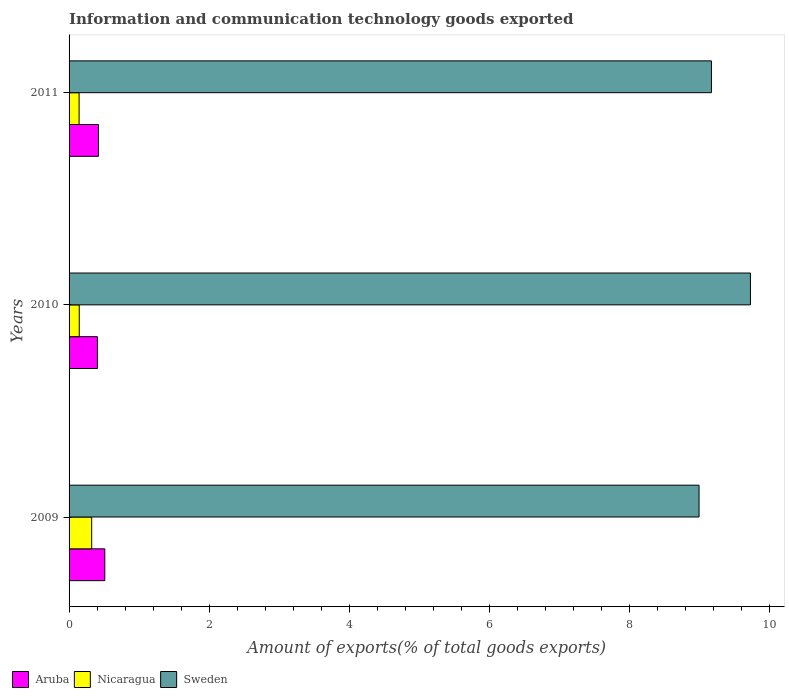Are the number of bars per tick equal to the number of legend labels?
Give a very brief answer. Yes. Are the number of bars on each tick of the Y-axis equal?
Your response must be concise. Yes. How many bars are there on the 2nd tick from the top?
Offer a terse response. 3. How many bars are there on the 3rd tick from the bottom?
Ensure brevity in your answer.  3. What is the label of the 2nd group of bars from the top?
Your answer should be compact. 2010. What is the amount of goods exported in Nicaragua in 2010?
Your answer should be very brief. 0.14. Across all years, what is the maximum amount of goods exported in Sweden?
Make the answer very short. 9.72. Across all years, what is the minimum amount of goods exported in Nicaragua?
Your answer should be compact. 0.14. In which year was the amount of goods exported in Sweden minimum?
Your answer should be very brief. 2009. What is the total amount of goods exported in Nicaragua in the graph?
Ensure brevity in your answer.  0.61. What is the difference between the amount of goods exported in Nicaragua in 2009 and that in 2010?
Your answer should be compact. 0.18. What is the difference between the amount of goods exported in Aruba in 2010 and the amount of goods exported in Sweden in 2009?
Your response must be concise. -8.59. What is the average amount of goods exported in Sweden per year?
Provide a succinct answer. 9.29. In the year 2010, what is the difference between the amount of goods exported in Aruba and amount of goods exported in Sweden?
Make the answer very short. -9.32. What is the ratio of the amount of goods exported in Sweden in 2010 to that in 2011?
Provide a succinct answer. 1.06. Is the amount of goods exported in Sweden in 2009 less than that in 2011?
Give a very brief answer. Yes. What is the difference between the highest and the second highest amount of goods exported in Nicaragua?
Give a very brief answer. 0.18. What is the difference between the highest and the lowest amount of goods exported in Nicaragua?
Provide a succinct answer. 0.18. In how many years, is the amount of goods exported in Aruba greater than the average amount of goods exported in Aruba taken over all years?
Make the answer very short. 1. Is the sum of the amount of goods exported in Sweden in 2009 and 2011 greater than the maximum amount of goods exported in Aruba across all years?
Provide a succinct answer. Yes. What does the 1st bar from the top in 2011 represents?
Ensure brevity in your answer.  Sweden. What does the 3rd bar from the bottom in 2009 represents?
Your answer should be very brief. Sweden. Are all the bars in the graph horizontal?
Provide a short and direct response. Yes. Are the values on the major ticks of X-axis written in scientific E-notation?
Give a very brief answer. No. Does the graph contain any zero values?
Offer a very short reply. No. Does the graph contain grids?
Your answer should be compact. No. How many legend labels are there?
Your answer should be very brief. 3. What is the title of the graph?
Your answer should be compact. Information and communication technology goods exported. What is the label or title of the X-axis?
Offer a terse response. Amount of exports(% of total goods exports). What is the label or title of the Y-axis?
Give a very brief answer. Years. What is the Amount of exports(% of total goods exports) in Aruba in 2009?
Keep it short and to the point. 0.51. What is the Amount of exports(% of total goods exports) in Nicaragua in 2009?
Make the answer very short. 0.32. What is the Amount of exports(% of total goods exports) in Sweden in 2009?
Provide a succinct answer. 8.99. What is the Amount of exports(% of total goods exports) of Aruba in 2010?
Give a very brief answer. 0.4. What is the Amount of exports(% of total goods exports) in Nicaragua in 2010?
Provide a succinct answer. 0.14. What is the Amount of exports(% of total goods exports) of Sweden in 2010?
Provide a short and direct response. 9.72. What is the Amount of exports(% of total goods exports) in Aruba in 2011?
Your response must be concise. 0.42. What is the Amount of exports(% of total goods exports) in Nicaragua in 2011?
Offer a terse response. 0.14. What is the Amount of exports(% of total goods exports) in Sweden in 2011?
Give a very brief answer. 9.17. Across all years, what is the maximum Amount of exports(% of total goods exports) of Aruba?
Make the answer very short. 0.51. Across all years, what is the maximum Amount of exports(% of total goods exports) in Nicaragua?
Offer a terse response. 0.32. Across all years, what is the maximum Amount of exports(% of total goods exports) in Sweden?
Keep it short and to the point. 9.72. Across all years, what is the minimum Amount of exports(% of total goods exports) in Aruba?
Offer a very short reply. 0.4. Across all years, what is the minimum Amount of exports(% of total goods exports) of Nicaragua?
Offer a terse response. 0.14. Across all years, what is the minimum Amount of exports(% of total goods exports) of Sweden?
Provide a short and direct response. 8.99. What is the total Amount of exports(% of total goods exports) of Aruba in the graph?
Offer a terse response. 1.33. What is the total Amount of exports(% of total goods exports) of Nicaragua in the graph?
Keep it short and to the point. 0.61. What is the total Amount of exports(% of total goods exports) in Sweden in the graph?
Give a very brief answer. 27.88. What is the difference between the Amount of exports(% of total goods exports) of Aruba in 2009 and that in 2010?
Make the answer very short. 0.11. What is the difference between the Amount of exports(% of total goods exports) in Nicaragua in 2009 and that in 2010?
Provide a succinct answer. 0.18. What is the difference between the Amount of exports(% of total goods exports) in Sweden in 2009 and that in 2010?
Your response must be concise. -0.73. What is the difference between the Amount of exports(% of total goods exports) of Aruba in 2009 and that in 2011?
Your answer should be compact. 0.09. What is the difference between the Amount of exports(% of total goods exports) in Nicaragua in 2009 and that in 2011?
Give a very brief answer. 0.18. What is the difference between the Amount of exports(% of total goods exports) in Sweden in 2009 and that in 2011?
Offer a terse response. -0.18. What is the difference between the Amount of exports(% of total goods exports) in Aruba in 2010 and that in 2011?
Offer a very short reply. -0.02. What is the difference between the Amount of exports(% of total goods exports) in Nicaragua in 2010 and that in 2011?
Offer a very short reply. 0. What is the difference between the Amount of exports(% of total goods exports) in Sweden in 2010 and that in 2011?
Provide a succinct answer. 0.56. What is the difference between the Amount of exports(% of total goods exports) in Aruba in 2009 and the Amount of exports(% of total goods exports) in Nicaragua in 2010?
Provide a short and direct response. 0.36. What is the difference between the Amount of exports(% of total goods exports) in Aruba in 2009 and the Amount of exports(% of total goods exports) in Sweden in 2010?
Keep it short and to the point. -9.21. What is the difference between the Amount of exports(% of total goods exports) of Nicaragua in 2009 and the Amount of exports(% of total goods exports) of Sweden in 2010?
Give a very brief answer. -9.4. What is the difference between the Amount of exports(% of total goods exports) in Aruba in 2009 and the Amount of exports(% of total goods exports) in Nicaragua in 2011?
Provide a short and direct response. 0.37. What is the difference between the Amount of exports(% of total goods exports) of Aruba in 2009 and the Amount of exports(% of total goods exports) of Sweden in 2011?
Ensure brevity in your answer.  -8.66. What is the difference between the Amount of exports(% of total goods exports) of Nicaragua in 2009 and the Amount of exports(% of total goods exports) of Sweden in 2011?
Ensure brevity in your answer.  -8.84. What is the difference between the Amount of exports(% of total goods exports) in Aruba in 2010 and the Amount of exports(% of total goods exports) in Nicaragua in 2011?
Give a very brief answer. 0.26. What is the difference between the Amount of exports(% of total goods exports) of Aruba in 2010 and the Amount of exports(% of total goods exports) of Sweden in 2011?
Offer a terse response. -8.76. What is the difference between the Amount of exports(% of total goods exports) in Nicaragua in 2010 and the Amount of exports(% of total goods exports) in Sweden in 2011?
Provide a succinct answer. -9.02. What is the average Amount of exports(% of total goods exports) of Aruba per year?
Your response must be concise. 0.44. What is the average Amount of exports(% of total goods exports) in Nicaragua per year?
Make the answer very short. 0.2. What is the average Amount of exports(% of total goods exports) of Sweden per year?
Offer a very short reply. 9.29. In the year 2009, what is the difference between the Amount of exports(% of total goods exports) in Aruba and Amount of exports(% of total goods exports) in Nicaragua?
Your answer should be very brief. 0.19. In the year 2009, what is the difference between the Amount of exports(% of total goods exports) in Aruba and Amount of exports(% of total goods exports) in Sweden?
Give a very brief answer. -8.48. In the year 2009, what is the difference between the Amount of exports(% of total goods exports) in Nicaragua and Amount of exports(% of total goods exports) in Sweden?
Offer a very short reply. -8.67. In the year 2010, what is the difference between the Amount of exports(% of total goods exports) of Aruba and Amount of exports(% of total goods exports) of Nicaragua?
Offer a terse response. 0.26. In the year 2010, what is the difference between the Amount of exports(% of total goods exports) of Aruba and Amount of exports(% of total goods exports) of Sweden?
Your response must be concise. -9.32. In the year 2010, what is the difference between the Amount of exports(% of total goods exports) of Nicaragua and Amount of exports(% of total goods exports) of Sweden?
Make the answer very short. -9.58. In the year 2011, what is the difference between the Amount of exports(% of total goods exports) of Aruba and Amount of exports(% of total goods exports) of Nicaragua?
Offer a very short reply. 0.28. In the year 2011, what is the difference between the Amount of exports(% of total goods exports) of Aruba and Amount of exports(% of total goods exports) of Sweden?
Provide a short and direct response. -8.75. In the year 2011, what is the difference between the Amount of exports(% of total goods exports) of Nicaragua and Amount of exports(% of total goods exports) of Sweden?
Your answer should be compact. -9.02. What is the ratio of the Amount of exports(% of total goods exports) in Aruba in 2009 to that in 2010?
Offer a very short reply. 1.26. What is the ratio of the Amount of exports(% of total goods exports) of Nicaragua in 2009 to that in 2010?
Offer a very short reply. 2.23. What is the ratio of the Amount of exports(% of total goods exports) of Sweden in 2009 to that in 2010?
Ensure brevity in your answer.  0.92. What is the ratio of the Amount of exports(% of total goods exports) of Aruba in 2009 to that in 2011?
Make the answer very short. 1.21. What is the ratio of the Amount of exports(% of total goods exports) in Nicaragua in 2009 to that in 2011?
Ensure brevity in your answer.  2.26. What is the ratio of the Amount of exports(% of total goods exports) in Sweden in 2009 to that in 2011?
Provide a succinct answer. 0.98. What is the ratio of the Amount of exports(% of total goods exports) of Aruba in 2010 to that in 2011?
Ensure brevity in your answer.  0.96. What is the ratio of the Amount of exports(% of total goods exports) of Nicaragua in 2010 to that in 2011?
Provide a short and direct response. 1.01. What is the ratio of the Amount of exports(% of total goods exports) in Sweden in 2010 to that in 2011?
Ensure brevity in your answer.  1.06. What is the difference between the highest and the second highest Amount of exports(% of total goods exports) in Aruba?
Your response must be concise. 0.09. What is the difference between the highest and the second highest Amount of exports(% of total goods exports) in Nicaragua?
Your response must be concise. 0.18. What is the difference between the highest and the second highest Amount of exports(% of total goods exports) in Sweden?
Your answer should be very brief. 0.56. What is the difference between the highest and the lowest Amount of exports(% of total goods exports) of Aruba?
Your answer should be very brief. 0.11. What is the difference between the highest and the lowest Amount of exports(% of total goods exports) of Nicaragua?
Offer a terse response. 0.18. What is the difference between the highest and the lowest Amount of exports(% of total goods exports) in Sweden?
Ensure brevity in your answer.  0.73. 